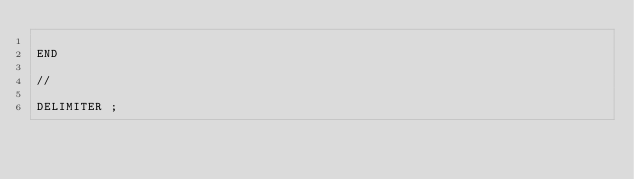<code> <loc_0><loc_0><loc_500><loc_500><_SQL_>
END

//

DELIMITER ;
</code> 